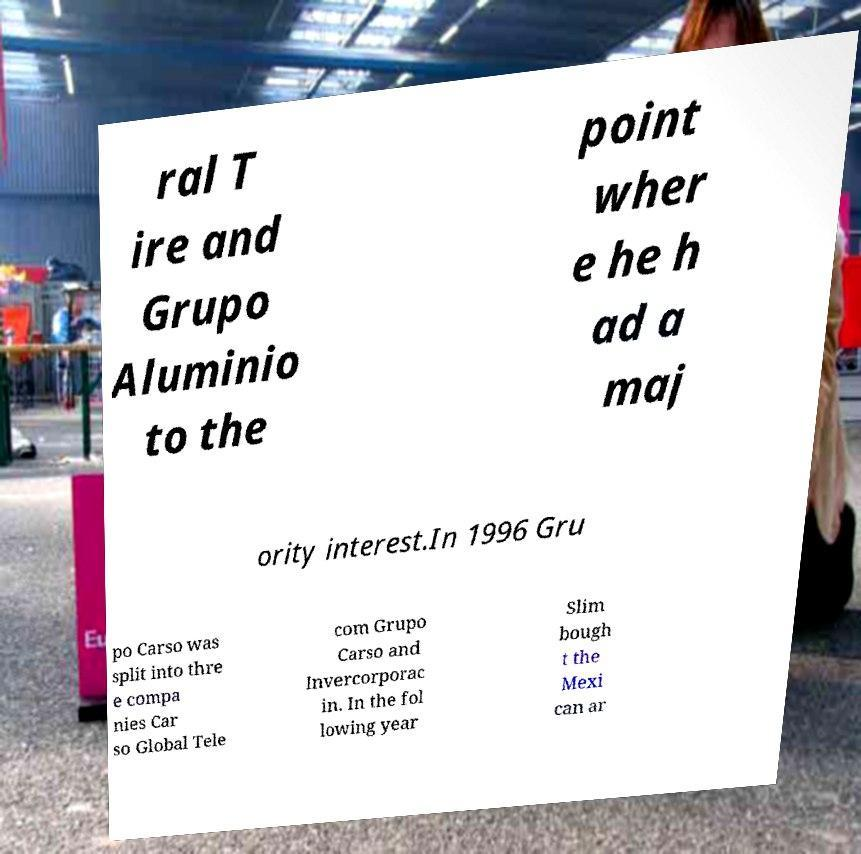Could you extract and type out the text from this image? ral T ire and Grupo Aluminio to the point wher e he h ad a maj ority interest.In 1996 Gru po Carso was split into thre e compa nies Car so Global Tele com Grupo Carso and Invercorporac in. In the fol lowing year Slim bough t the Mexi can ar 